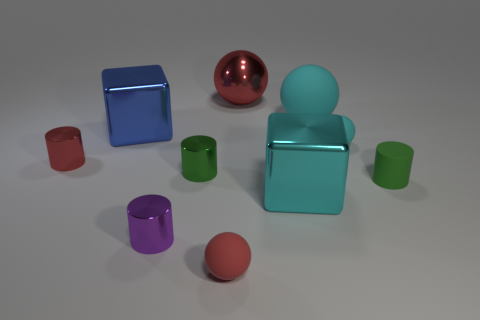Does the red matte thing have the same size as the matte cylinder?
Make the answer very short. Yes. The cyan metal cube has what size?
Ensure brevity in your answer.  Large. There is a object that is the same color as the small rubber cylinder; what shape is it?
Provide a succinct answer. Cylinder. Is the number of tiny purple cylinders greater than the number of tiny red objects?
Keep it short and to the point. No. What is the color of the ball in front of the tiny matte object behind the tiny shiny cylinder that is to the right of the purple shiny cylinder?
Your response must be concise. Red. Do the red shiny thing in front of the large shiny ball and the small cyan thing have the same shape?
Ensure brevity in your answer.  No. There is another matte cylinder that is the same size as the red cylinder; what color is it?
Offer a terse response. Green. How many small cyan rubber spheres are there?
Offer a terse response. 1. Is the material of the large cyan object behind the red shiny cylinder the same as the small red sphere?
Provide a succinct answer. Yes. What material is the object that is both to the left of the cyan metallic thing and right of the tiny red rubber object?
Offer a very short reply. Metal. 